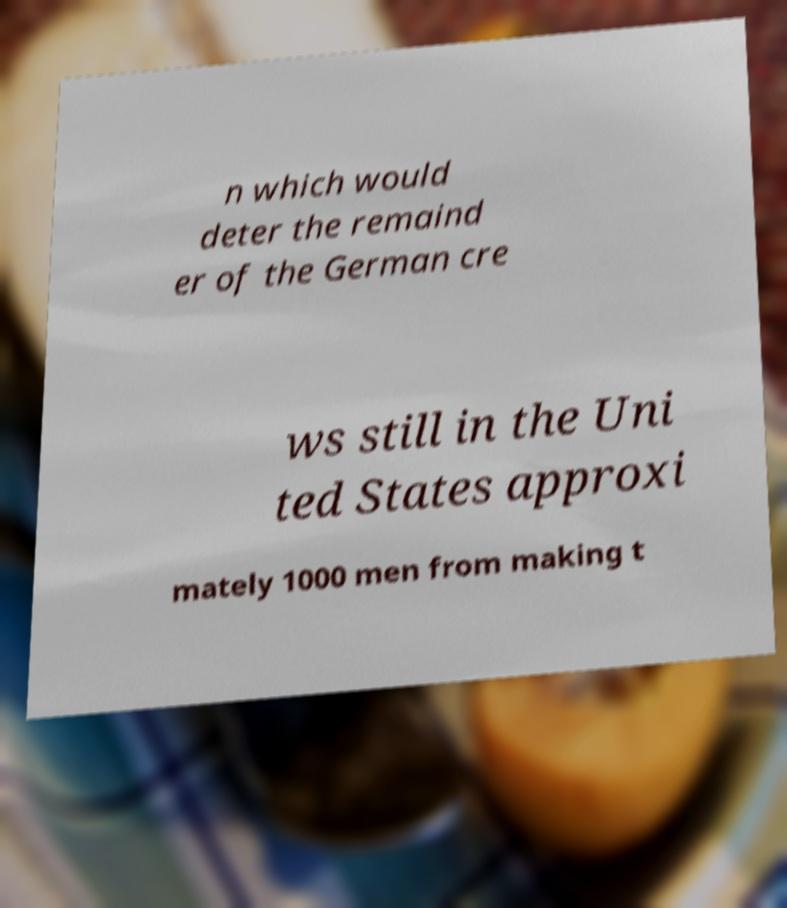I need the written content from this picture converted into text. Can you do that? n which would deter the remaind er of the German cre ws still in the Uni ted States approxi mately 1000 men from making t 